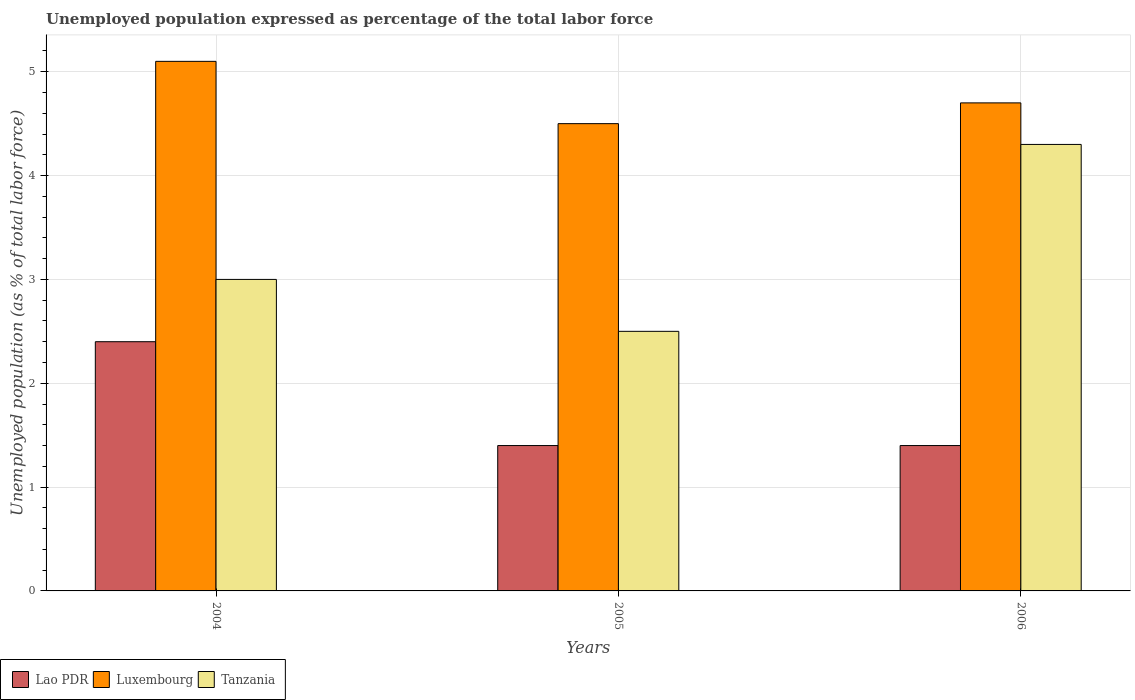How many groups of bars are there?
Offer a very short reply. 3. Are the number of bars per tick equal to the number of legend labels?
Your answer should be very brief. Yes. Are the number of bars on each tick of the X-axis equal?
Offer a very short reply. Yes. How many bars are there on the 2nd tick from the left?
Give a very brief answer. 3. In how many cases, is the number of bars for a given year not equal to the number of legend labels?
Offer a very short reply. 0. What is the unemployment in in Tanzania in 2005?
Give a very brief answer. 2.5. Across all years, what is the maximum unemployment in in Luxembourg?
Keep it short and to the point. 5.1. What is the total unemployment in in Luxembourg in the graph?
Provide a succinct answer. 14.3. What is the difference between the unemployment in in Tanzania in 2005 and that in 2006?
Your answer should be compact. -1.8. What is the difference between the unemployment in in Tanzania in 2005 and the unemployment in in Lao PDR in 2006?
Your answer should be compact. 1.1. What is the average unemployment in in Luxembourg per year?
Offer a terse response. 4.77. What is the ratio of the unemployment in in Lao PDR in 2004 to that in 2006?
Make the answer very short. 1.71. Is the unemployment in in Tanzania in 2004 less than that in 2006?
Provide a succinct answer. Yes. What is the difference between the highest and the second highest unemployment in in Tanzania?
Your answer should be very brief. 1.3. What is the difference between the highest and the lowest unemployment in in Luxembourg?
Make the answer very short. 0.6. In how many years, is the unemployment in in Luxembourg greater than the average unemployment in in Luxembourg taken over all years?
Keep it short and to the point. 1. Is the sum of the unemployment in in Lao PDR in 2004 and 2005 greater than the maximum unemployment in in Luxembourg across all years?
Your response must be concise. No. What does the 2nd bar from the left in 2006 represents?
Give a very brief answer. Luxembourg. What does the 3rd bar from the right in 2004 represents?
Your answer should be compact. Lao PDR. Is it the case that in every year, the sum of the unemployment in in Tanzania and unemployment in in Luxembourg is greater than the unemployment in in Lao PDR?
Offer a terse response. Yes. How many bars are there?
Offer a terse response. 9. How many years are there in the graph?
Offer a very short reply. 3. What is the difference between two consecutive major ticks on the Y-axis?
Offer a terse response. 1. Does the graph contain any zero values?
Make the answer very short. No. Where does the legend appear in the graph?
Your response must be concise. Bottom left. How are the legend labels stacked?
Keep it short and to the point. Horizontal. What is the title of the graph?
Keep it short and to the point. Unemployed population expressed as percentage of the total labor force. Does "Kosovo" appear as one of the legend labels in the graph?
Offer a very short reply. No. What is the label or title of the X-axis?
Give a very brief answer. Years. What is the label or title of the Y-axis?
Your response must be concise. Unemployed population (as % of total labor force). What is the Unemployed population (as % of total labor force) in Lao PDR in 2004?
Make the answer very short. 2.4. What is the Unemployed population (as % of total labor force) of Luxembourg in 2004?
Your response must be concise. 5.1. What is the Unemployed population (as % of total labor force) in Tanzania in 2004?
Keep it short and to the point. 3. What is the Unemployed population (as % of total labor force) of Lao PDR in 2005?
Offer a very short reply. 1.4. What is the Unemployed population (as % of total labor force) of Luxembourg in 2005?
Your answer should be very brief. 4.5. What is the Unemployed population (as % of total labor force) in Tanzania in 2005?
Offer a very short reply. 2.5. What is the Unemployed population (as % of total labor force) in Lao PDR in 2006?
Your response must be concise. 1.4. What is the Unemployed population (as % of total labor force) in Luxembourg in 2006?
Offer a very short reply. 4.7. What is the Unemployed population (as % of total labor force) in Tanzania in 2006?
Keep it short and to the point. 4.3. Across all years, what is the maximum Unemployed population (as % of total labor force) of Lao PDR?
Keep it short and to the point. 2.4. Across all years, what is the maximum Unemployed population (as % of total labor force) of Luxembourg?
Keep it short and to the point. 5.1. Across all years, what is the maximum Unemployed population (as % of total labor force) in Tanzania?
Provide a succinct answer. 4.3. Across all years, what is the minimum Unemployed population (as % of total labor force) of Lao PDR?
Your answer should be very brief. 1.4. Across all years, what is the minimum Unemployed population (as % of total labor force) of Tanzania?
Your answer should be very brief. 2.5. What is the total Unemployed population (as % of total labor force) in Lao PDR in the graph?
Your answer should be compact. 5.2. What is the total Unemployed population (as % of total labor force) in Tanzania in the graph?
Keep it short and to the point. 9.8. What is the difference between the Unemployed population (as % of total labor force) of Luxembourg in 2004 and that in 2005?
Give a very brief answer. 0.6. What is the difference between the Unemployed population (as % of total labor force) in Lao PDR in 2004 and that in 2006?
Provide a succinct answer. 1. What is the difference between the Unemployed population (as % of total labor force) of Luxembourg in 2005 and that in 2006?
Ensure brevity in your answer.  -0.2. What is the difference between the Unemployed population (as % of total labor force) in Lao PDR in 2004 and the Unemployed population (as % of total labor force) in Luxembourg in 2005?
Provide a succinct answer. -2.1. What is the difference between the Unemployed population (as % of total labor force) in Lao PDR in 2004 and the Unemployed population (as % of total labor force) in Tanzania in 2005?
Your answer should be very brief. -0.1. What is the difference between the Unemployed population (as % of total labor force) of Lao PDR in 2004 and the Unemployed population (as % of total labor force) of Luxembourg in 2006?
Ensure brevity in your answer.  -2.3. What is the difference between the Unemployed population (as % of total labor force) of Lao PDR in 2004 and the Unemployed population (as % of total labor force) of Tanzania in 2006?
Offer a terse response. -1.9. What is the difference between the Unemployed population (as % of total labor force) of Lao PDR in 2005 and the Unemployed population (as % of total labor force) of Luxembourg in 2006?
Your answer should be compact. -3.3. What is the difference between the Unemployed population (as % of total labor force) of Luxembourg in 2005 and the Unemployed population (as % of total labor force) of Tanzania in 2006?
Make the answer very short. 0.2. What is the average Unemployed population (as % of total labor force) in Lao PDR per year?
Ensure brevity in your answer.  1.73. What is the average Unemployed population (as % of total labor force) of Luxembourg per year?
Provide a succinct answer. 4.77. What is the average Unemployed population (as % of total labor force) of Tanzania per year?
Keep it short and to the point. 3.27. In the year 2006, what is the difference between the Unemployed population (as % of total labor force) in Lao PDR and Unemployed population (as % of total labor force) in Luxembourg?
Make the answer very short. -3.3. What is the ratio of the Unemployed population (as % of total labor force) in Lao PDR in 2004 to that in 2005?
Your answer should be compact. 1.71. What is the ratio of the Unemployed population (as % of total labor force) of Luxembourg in 2004 to that in 2005?
Provide a succinct answer. 1.13. What is the ratio of the Unemployed population (as % of total labor force) in Lao PDR in 2004 to that in 2006?
Offer a terse response. 1.71. What is the ratio of the Unemployed population (as % of total labor force) of Luxembourg in 2004 to that in 2006?
Make the answer very short. 1.09. What is the ratio of the Unemployed population (as % of total labor force) in Tanzania in 2004 to that in 2006?
Your answer should be very brief. 0.7. What is the ratio of the Unemployed population (as % of total labor force) in Lao PDR in 2005 to that in 2006?
Keep it short and to the point. 1. What is the ratio of the Unemployed population (as % of total labor force) in Luxembourg in 2005 to that in 2006?
Your answer should be very brief. 0.96. What is the ratio of the Unemployed population (as % of total labor force) of Tanzania in 2005 to that in 2006?
Give a very brief answer. 0.58. What is the difference between the highest and the second highest Unemployed population (as % of total labor force) of Luxembourg?
Offer a terse response. 0.4. What is the difference between the highest and the lowest Unemployed population (as % of total labor force) in Lao PDR?
Make the answer very short. 1. 